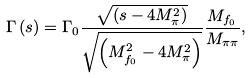Convert formula to latex. <formula><loc_0><loc_0><loc_500><loc_500>\Gamma \left ( s \right ) = \Gamma _ { 0 } \frac { \sqrt { \left ( s - 4 M ^ { 2 } _ { \pi } \right ) } } { \sqrt { \left ( M _ { f _ { 0 } } ^ { 2 } - 4 M ^ { 2 } _ { \pi } \right ) } } \frac { M _ { f _ { 0 } } } { M _ { \pi \pi } } ,</formula> 